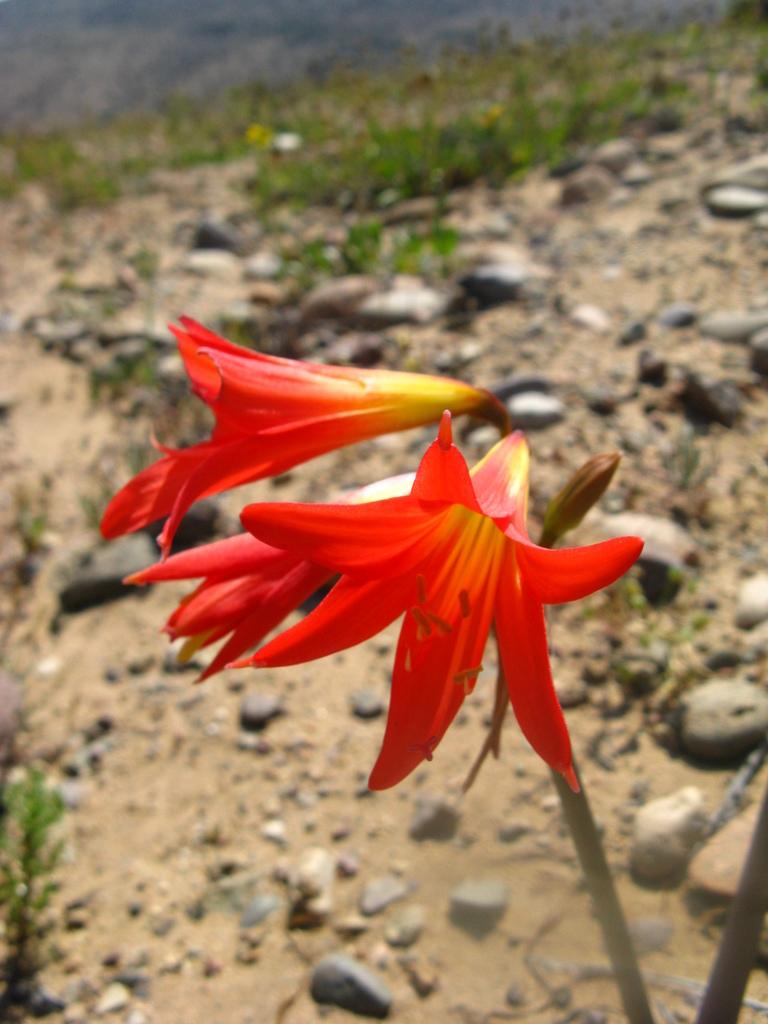What is the main subject in the middle of the image? There are flowers in the middle of the image. What can be seen in the background of the image? There are stones and grass in the background of the image. What type of cork can be seen floating in the water in the image? There is no water or cork present in the image; it features flowers, stones, and grass. 